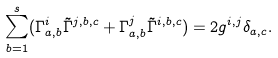<formula> <loc_0><loc_0><loc_500><loc_500>\sum _ { b = 1 } ^ { s } ( \Gamma ^ { i } _ { a , b } \tilde { \Gamma } ^ { j , b , c } + \Gamma ^ { j } _ { a , b } \tilde { \Gamma } ^ { i , b , c } ) = 2 g ^ { i , j } \delta _ { a , c } .</formula> 